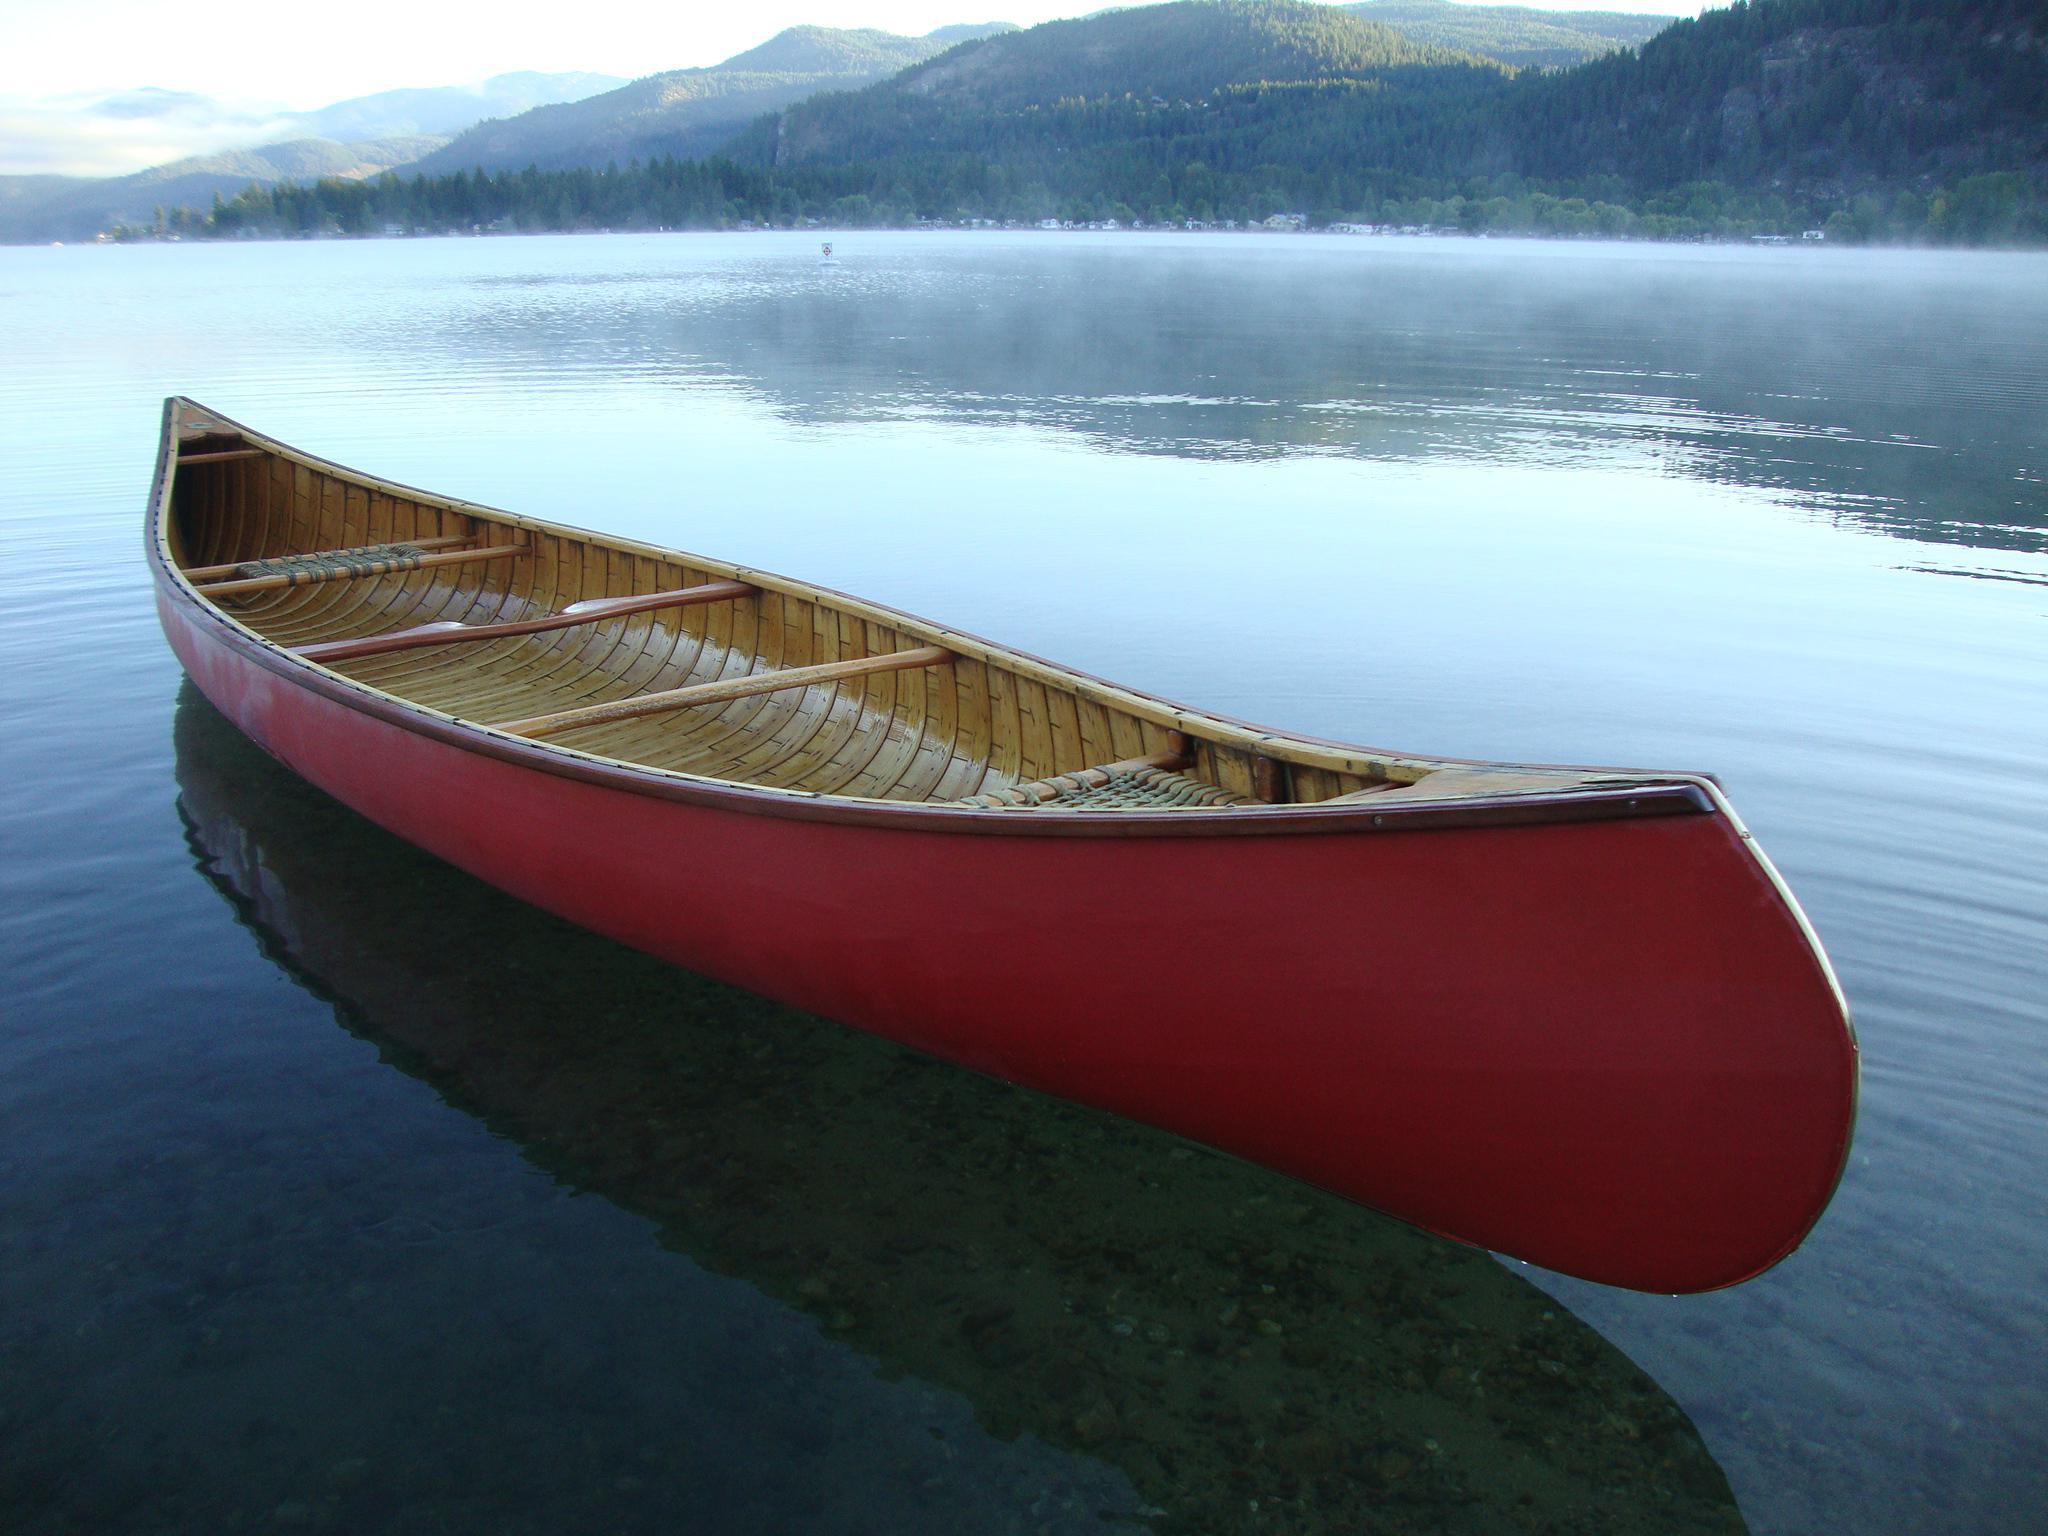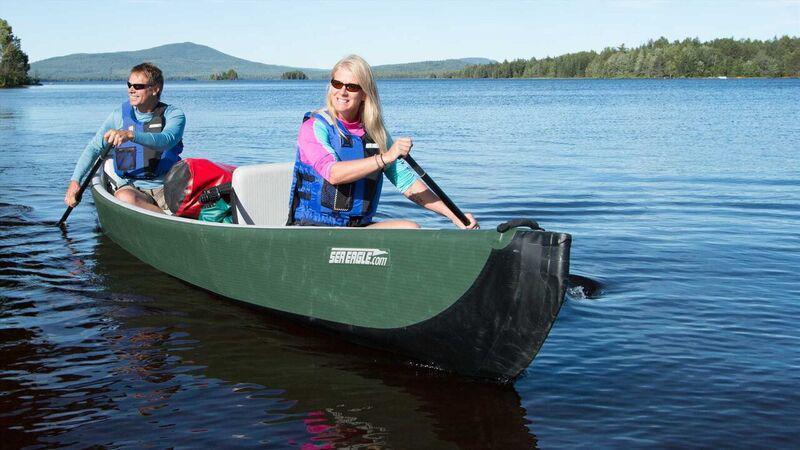The first image is the image on the left, the second image is the image on the right. For the images displayed, is the sentence "In one image, exactly two people, a man and a woman, are rowing a green canoe." factually correct? Answer yes or no. Yes. The first image is the image on the left, the second image is the image on the right. Considering the images on both sides, is "An image shows one dark green canoe with two riders." valid? Answer yes or no. Yes. 